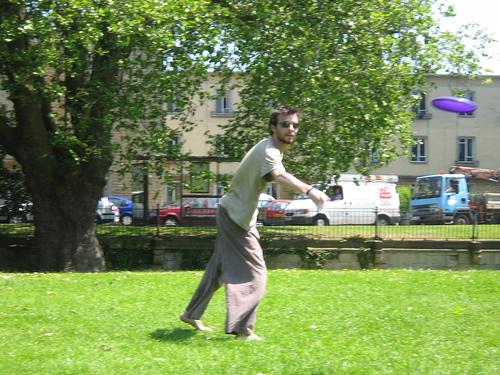How many trucks are there?
Answer briefly. 1. What is the man throwing?
Concise answer only. Frisbee. What color is the grass?
Write a very short answer. Green. 